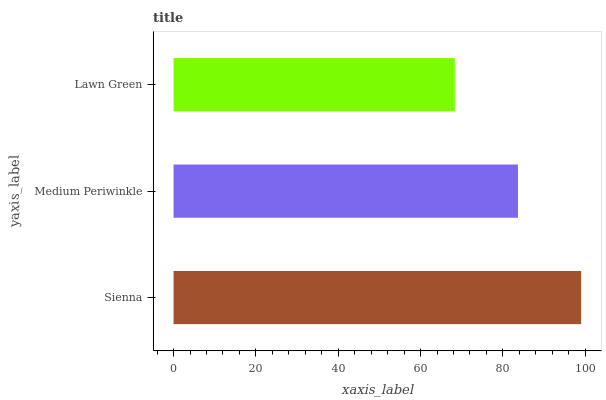Is Lawn Green the minimum?
Answer yes or no. Yes. Is Sienna the maximum?
Answer yes or no. Yes. Is Medium Periwinkle the minimum?
Answer yes or no. No. Is Medium Periwinkle the maximum?
Answer yes or no. No. Is Sienna greater than Medium Periwinkle?
Answer yes or no. Yes. Is Medium Periwinkle less than Sienna?
Answer yes or no. Yes. Is Medium Periwinkle greater than Sienna?
Answer yes or no. No. Is Sienna less than Medium Periwinkle?
Answer yes or no. No. Is Medium Periwinkle the high median?
Answer yes or no. Yes. Is Medium Periwinkle the low median?
Answer yes or no. Yes. Is Sienna the high median?
Answer yes or no. No. Is Sienna the low median?
Answer yes or no. No. 